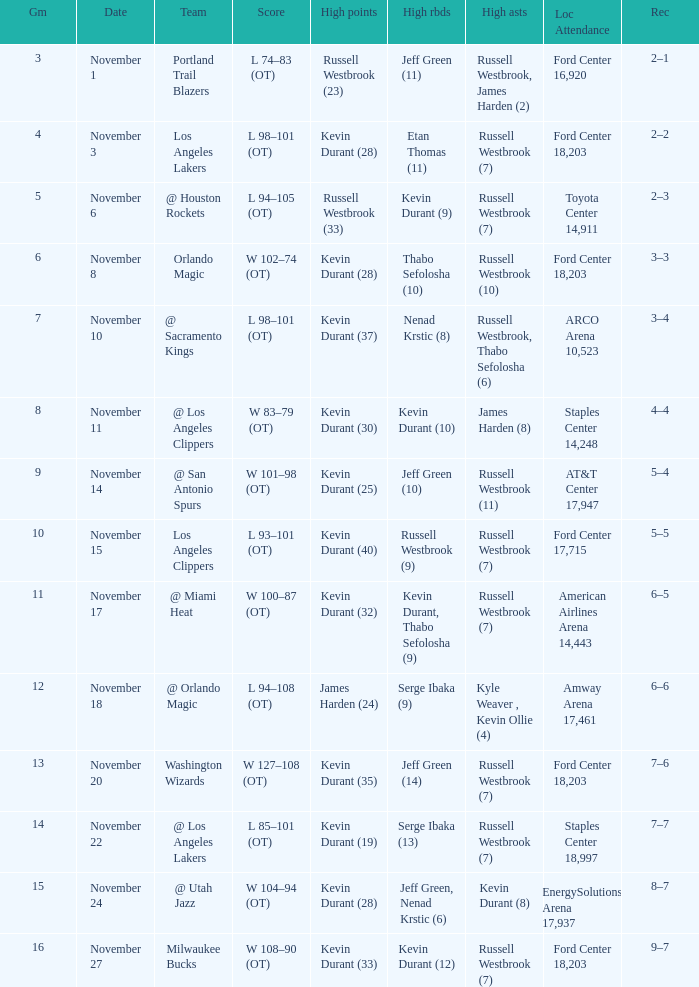When was the game number 3 played? November 1. 